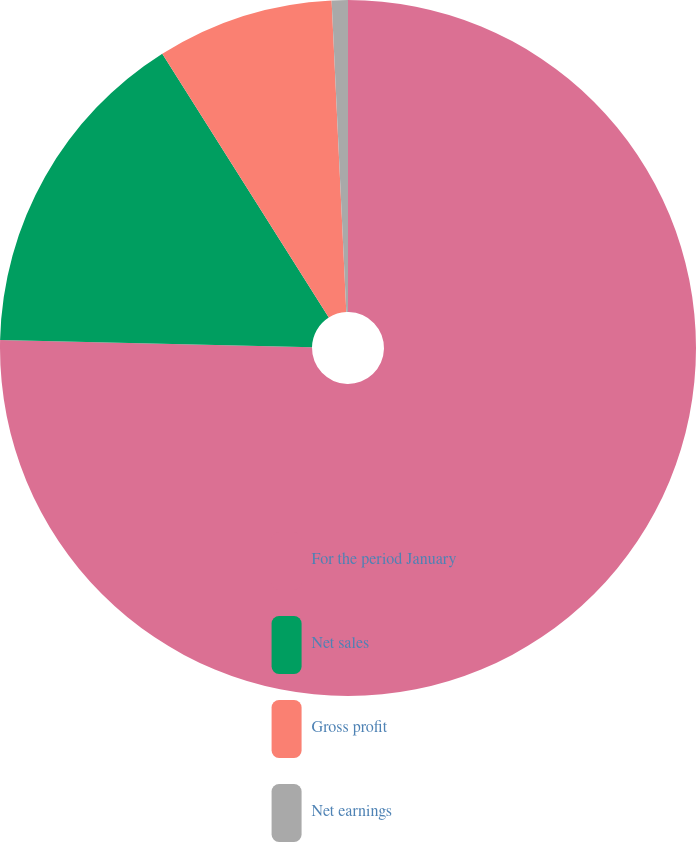Convert chart to OTSL. <chart><loc_0><loc_0><loc_500><loc_500><pie_chart><fcel>For the period January<fcel>Net sales<fcel>Gross profit<fcel>Net earnings<nl><fcel>75.37%<fcel>15.67%<fcel>8.21%<fcel>0.75%<nl></chart> 